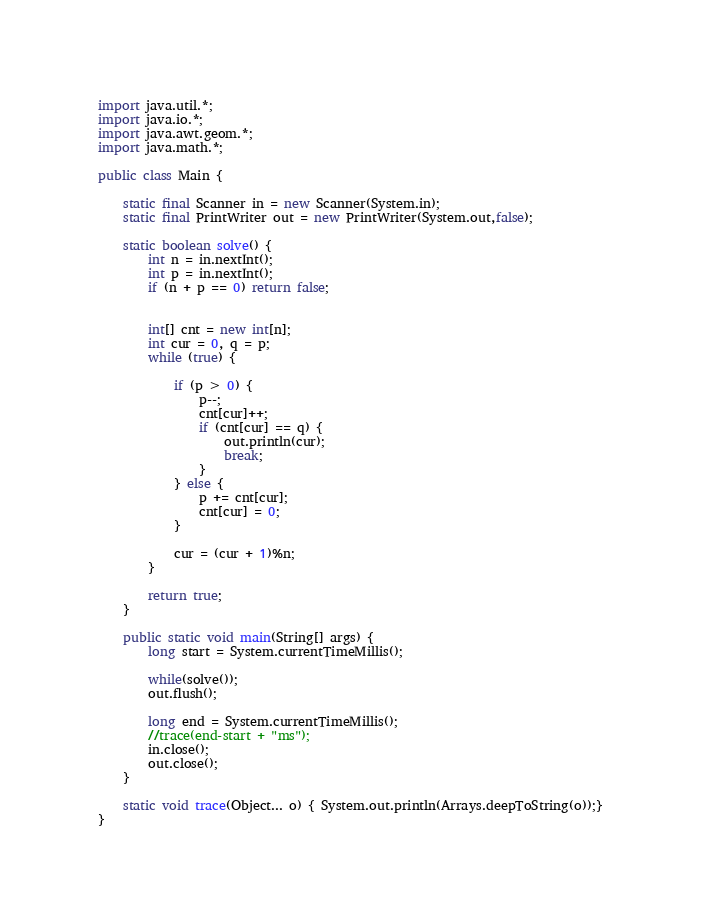Convert code to text. <code><loc_0><loc_0><loc_500><loc_500><_Java_>import java.util.*;
import java.io.*;
import java.awt.geom.*;
import java.math.*;

public class Main {

	static final Scanner in = new Scanner(System.in);
	static final PrintWriter out = new PrintWriter(System.out,false);

	static boolean solve() {
		int n = in.nextInt();
		int p = in.nextInt();
		if (n + p == 0) return false;


		int[] cnt = new int[n];
		int cur = 0, q = p;
		while (true) {

			if (p > 0) {
				p--;
				cnt[cur]++;
				if (cnt[cur] == q) {
					out.println(cur);
					break;
				}
			} else {
				p += cnt[cur];
				cnt[cur] = 0;
			}

			cur = (cur + 1)%n;
		}

		return true;
	}

	public static void main(String[] args) {
		long start = System.currentTimeMillis();

		while(solve());
		out.flush();

		long end = System.currentTimeMillis();
		//trace(end-start + "ms");
		in.close();
		out.close();
	}

	static void trace(Object... o) { System.out.println(Arrays.deepToString(o));}
}</code> 